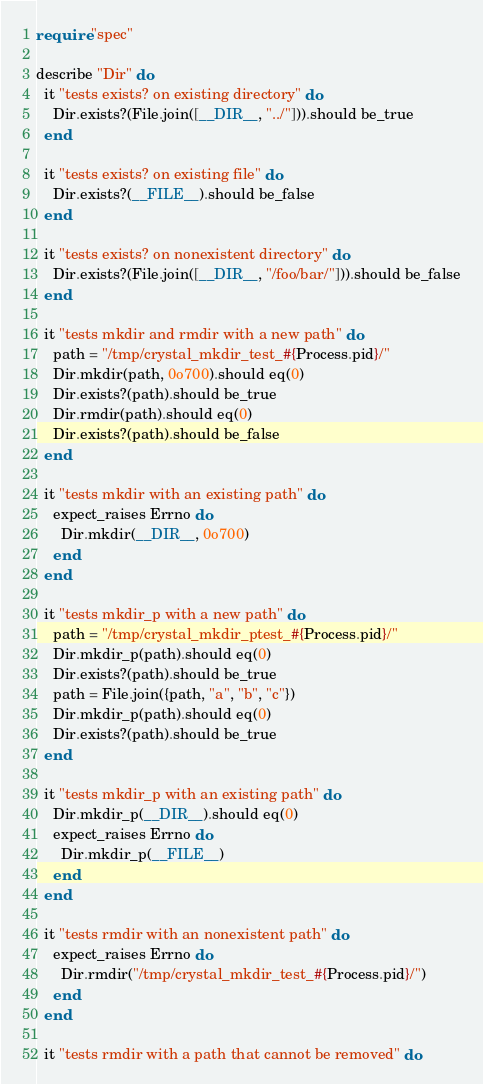<code> <loc_0><loc_0><loc_500><loc_500><_Crystal_>require "spec"

describe "Dir" do
  it "tests exists? on existing directory" do
    Dir.exists?(File.join([__DIR__, "../"])).should be_true
  end

  it "tests exists? on existing file" do
    Dir.exists?(__FILE__).should be_false
  end

  it "tests exists? on nonexistent directory" do
    Dir.exists?(File.join([__DIR__, "/foo/bar/"])).should be_false
  end

  it "tests mkdir and rmdir with a new path" do
    path = "/tmp/crystal_mkdir_test_#{Process.pid}/"
    Dir.mkdir(path, 0o700).should eq(0)
    Dir.exists?(path).should be_true
    Dir.rmdir(path).should eq(0)
    Dir.exists?(path).should be_false
  end

  it "tests mkdir with an existing path" do
    expect_raises Errno do
      Dir.mkdir(__DIR__, 0o700)
    end
  end

  it "tests mkdir_p with a new path" do
    path = "/tmp/crystal_mkdir_ptest_#{Process.pid}/"
    Dir.mkdir_p(path).should eq(0)
    Dir.exists?(path).should be_true
    path = File.join({path, "a", "b", "c"})
    Dir.mkdir_p(path).should eq(0)
    Dir.exists?(path).should be_true
  end

  it "tests mkdir_p with an existing path" do
    Dir.mkdir_p(__DIR__).should eq(0)
    expect_raises Errno do
      Dir.mkdir_p(__FILE__)
    end
  end

  it "tests rmdir with an nonexistent path" do
    expect_raises Errno do
      Dir.rmdir("/tmp/crystal_mkdir_test_#{Process.pid}/")
    end
  end

  it "tests rmdir with a path that cannot be removed" do</code> 